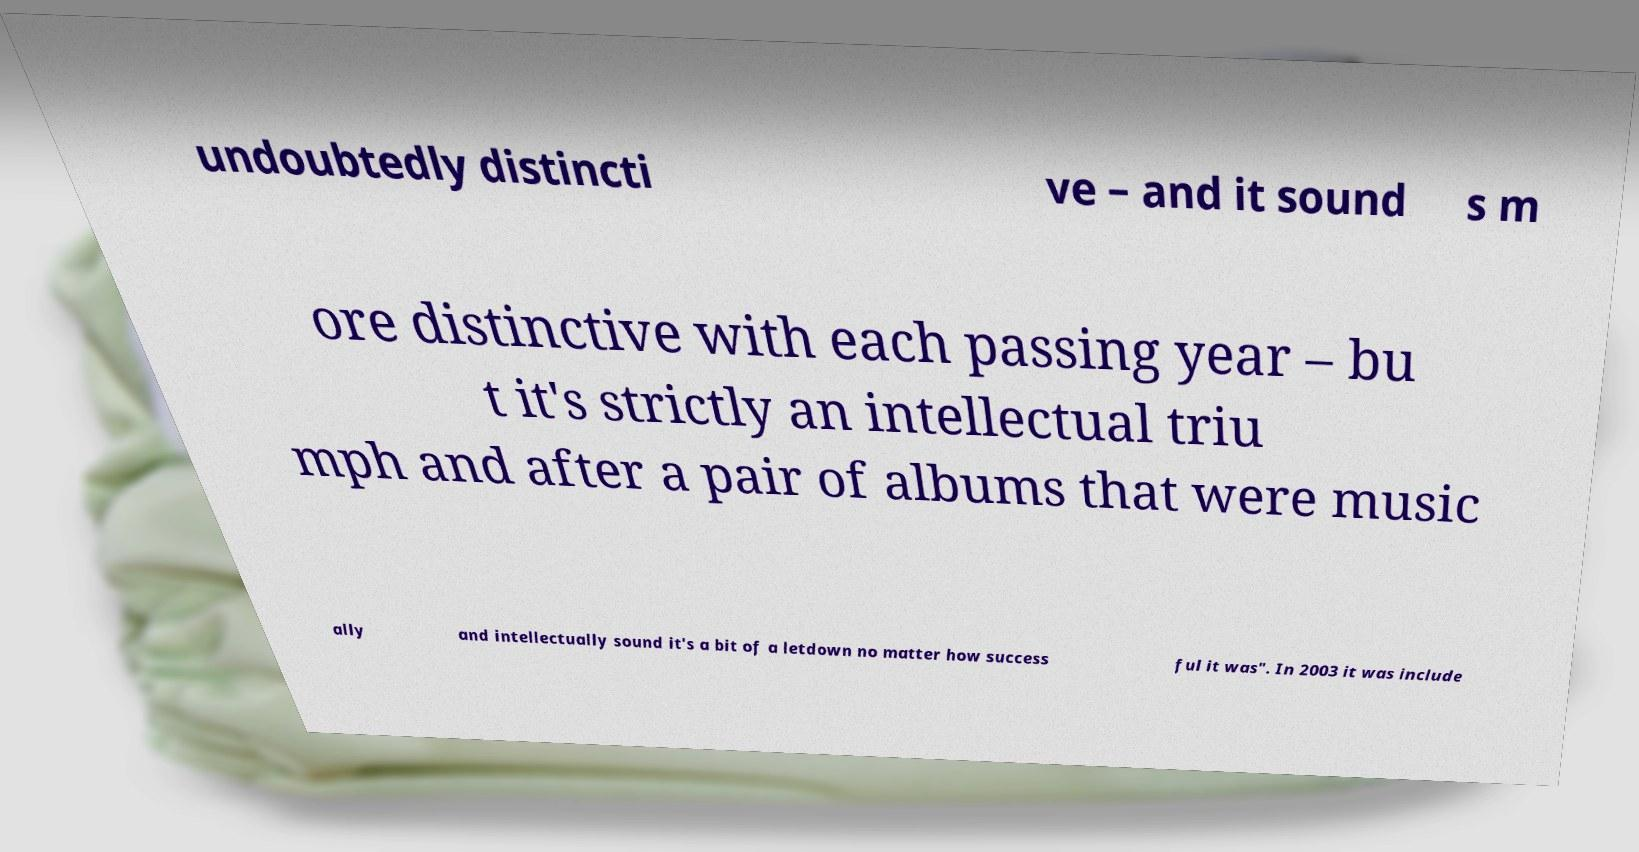There's text embedded in this image that I need extracted. Can you transcribe it verbatim? undoubtedly distincti ve – and it sound s m ore distinctive with each passing year – bu t it's strictly an intellectual triu mph and after a pair of albums that were music ally and intellectually sound it's a bit of a letdown no matter how success ful it was". In 2003 it was include 